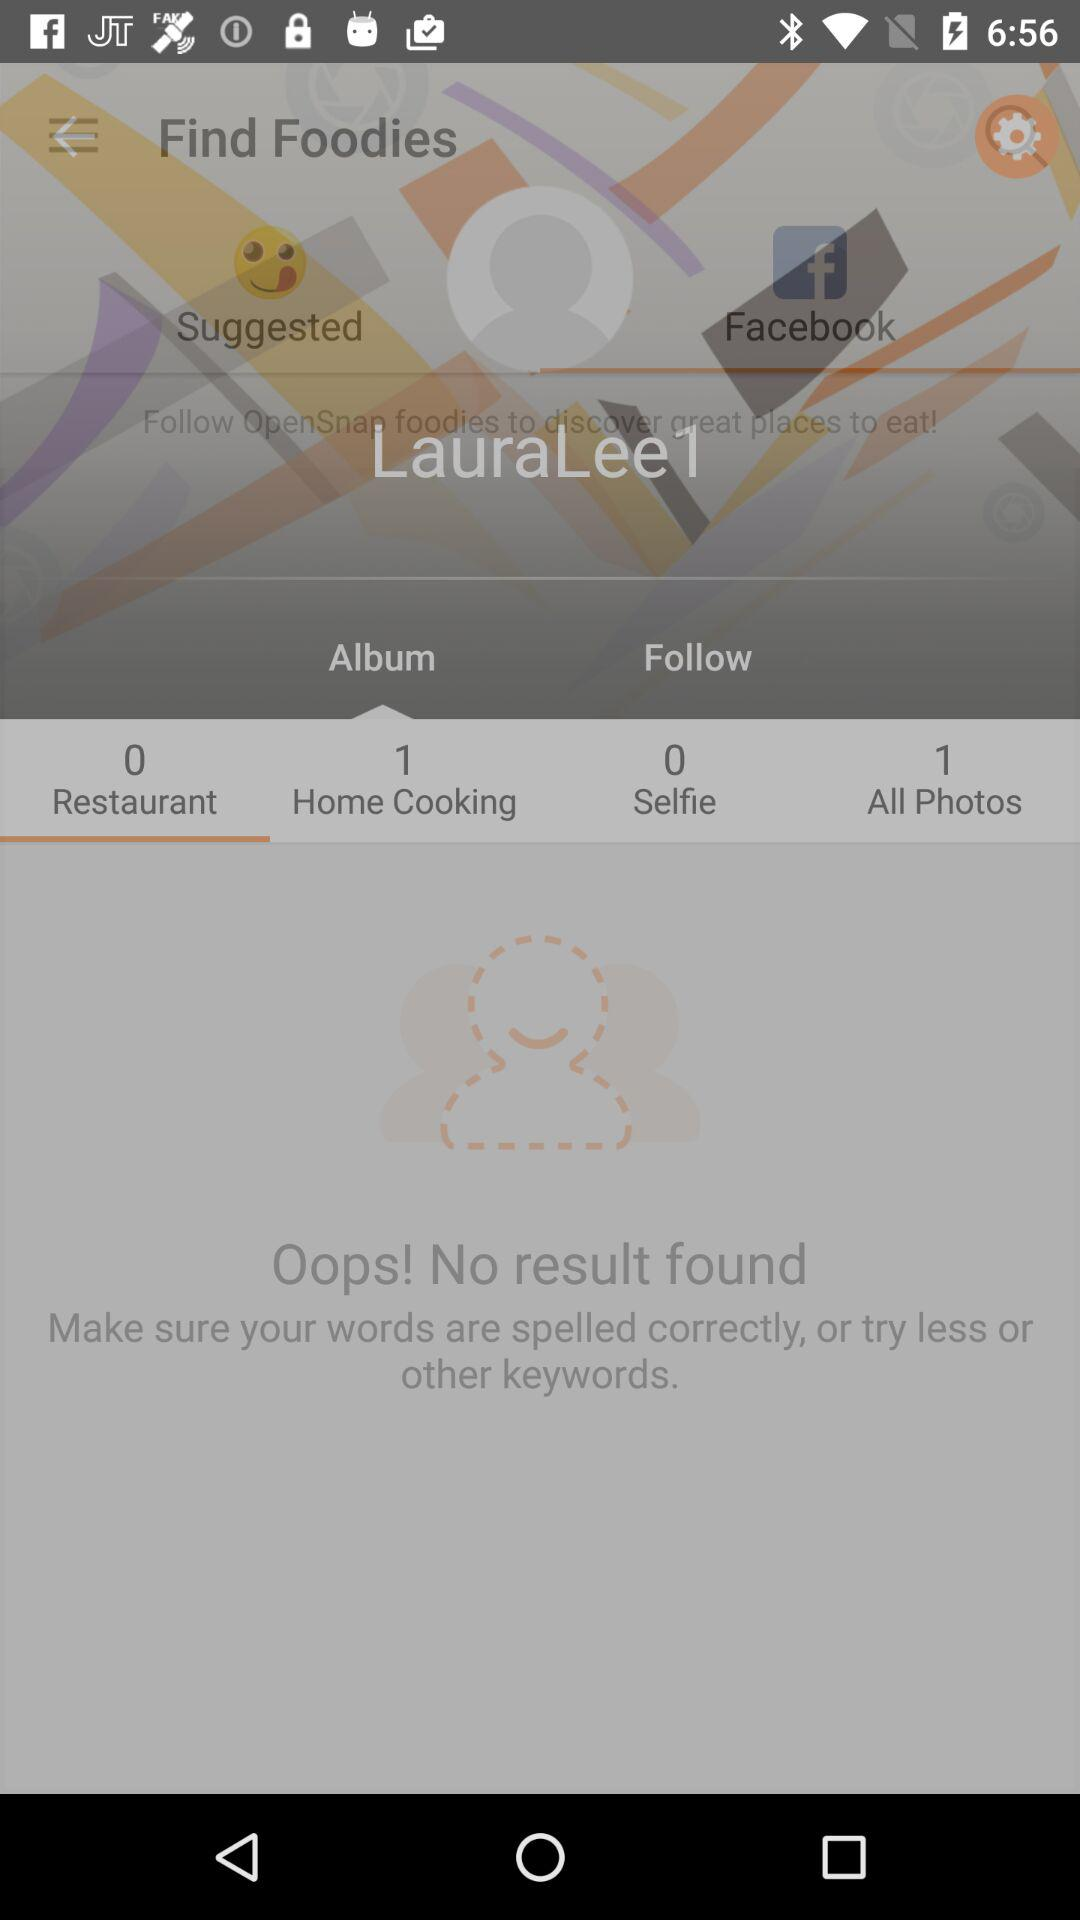Which tab is selected? The selected tabs are "Facebook", "Album" and "Restaurant". 